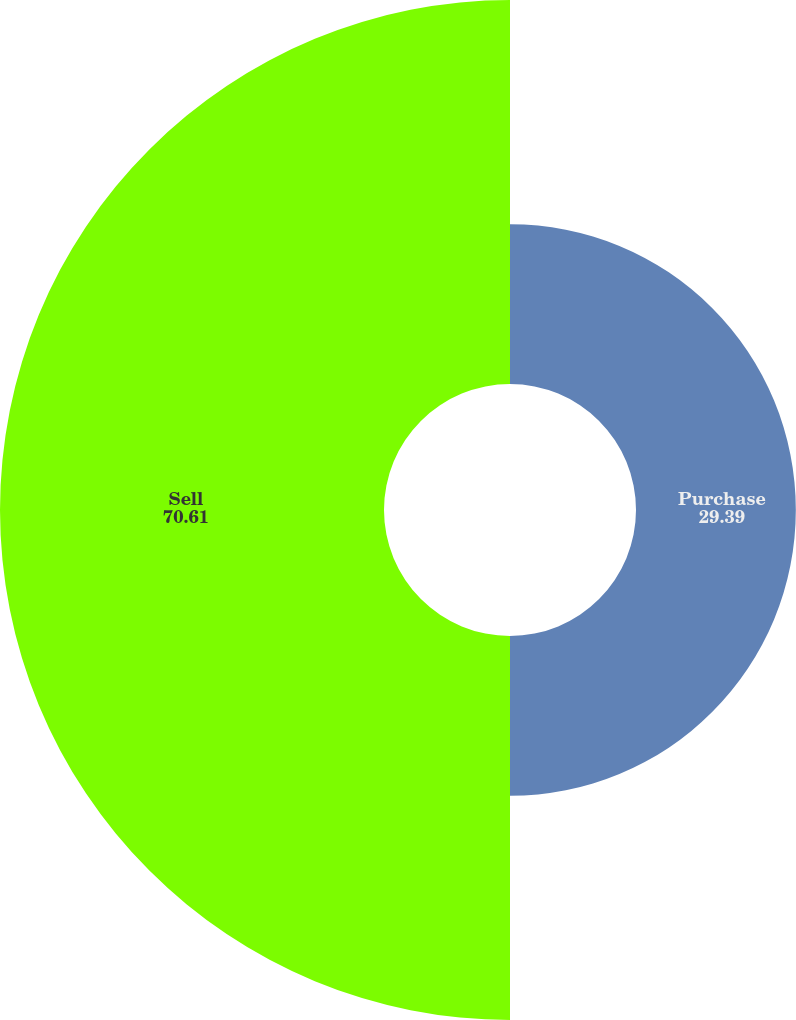Convert chart to OTSL. <chart><loc_0><loc_0><loc_500><loc_500><pie_chart><fcel>Purchase<fcel>Sell<nl><fcel>29.39%<fcel>70.61%<nl></chart> 